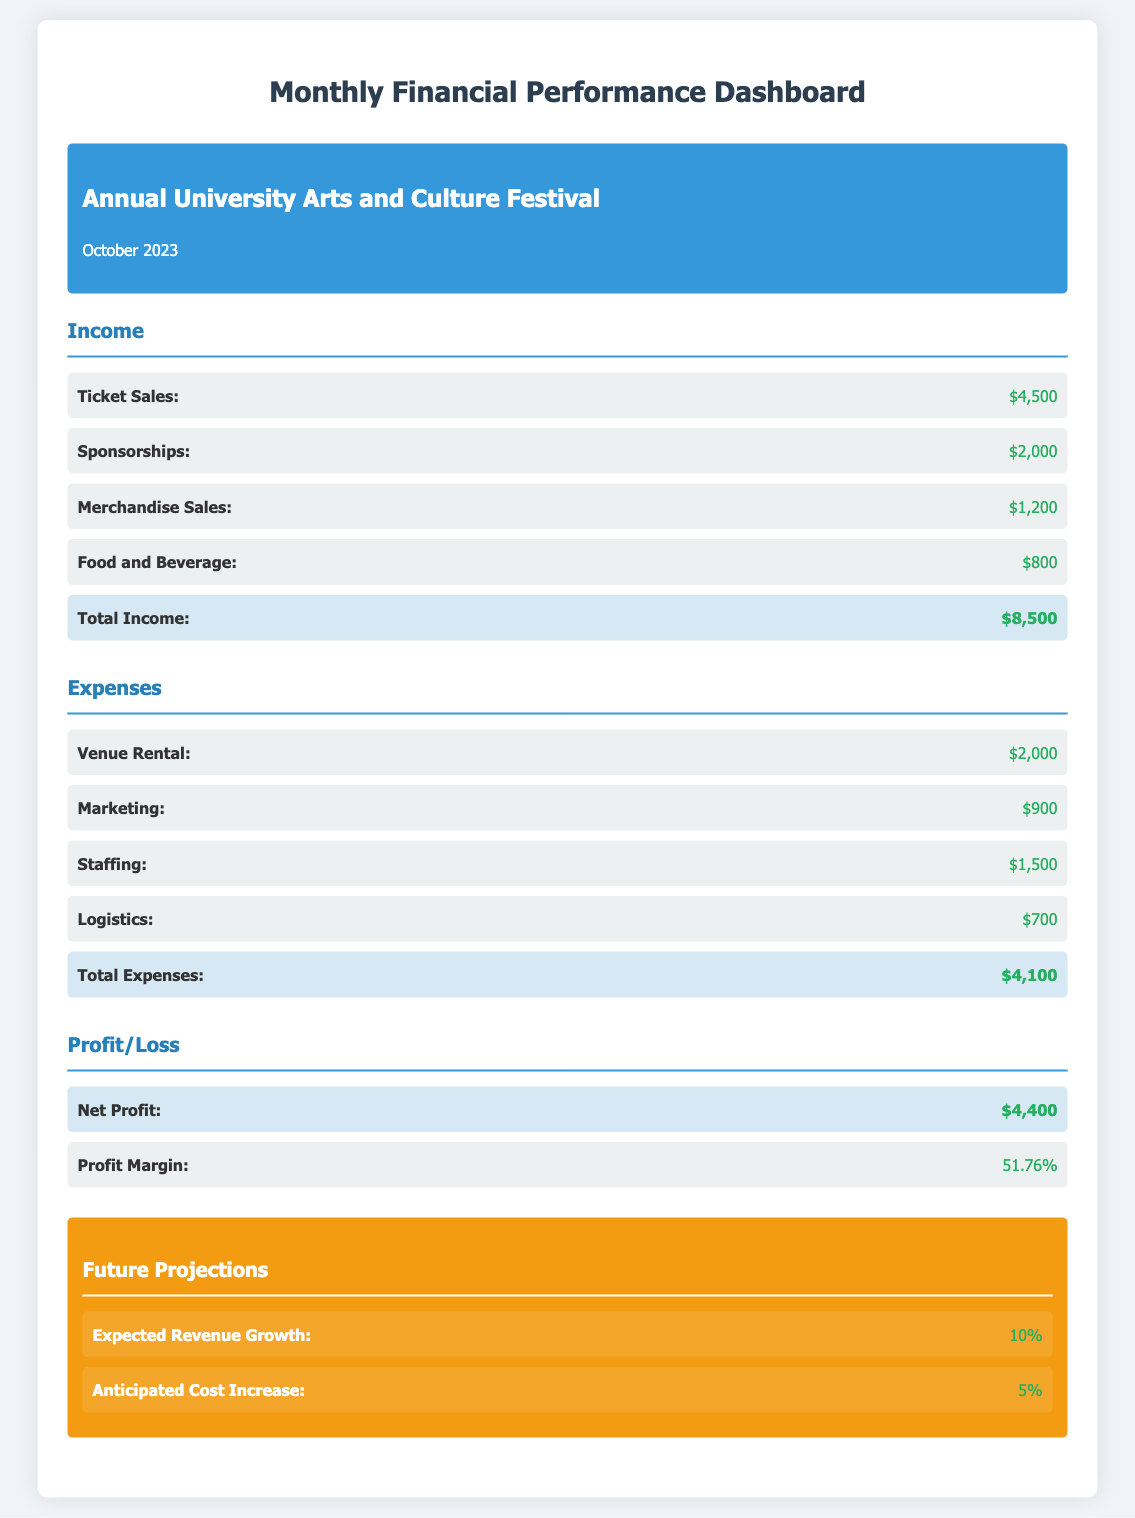What is the total income? The total income is calculated by summing all the income sources listed in the document: Ticket Sales, Sponsorships, Merchandise Sales, and Food and Beverage.
Answer: $8,500 What are the expenses for marketing? The document specifies the expenses related to marketing, which is clearly outlined under the Expenses section.
Answer: $900 What is the net profit? The net profit is indicated in the Profit/Loss section as the difference between total income and total expenses.
Answer: $4,400 What is the profit margin? Profit margin is defined in the document as a percentage, which reflects the net profit relative to total income.
Answer: 51.76% What is the expected revenue growth? The expected revenue growth is stated in the Future Projections section of the document.
Answer: 10% What was the total expense for venue rental? The total expense for venue rental is specifically listed in the Expenses section for transparency.
Answer: $2,000 What is the anticipated cost increase? The anticipated cost increase is provided in the Future Projections section and reflects predicted changes in expenses.
Answer: 5% What is the total revenue from ticket sales? The document breaks down the income sources and clearly lists the revenue from ticket sales.
Answer: $4,500 What section of the dashboard details the profit and loss? The Profit/Loss section shows computed financial results stemming from income and expenses.
Answer: Profit/Loss 